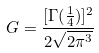<formula> <loc_0><loc_0><loc_500><loc_500>G = \frac { [ \Gamma ( \frac { 1 } { 4 } ) ] ^ { 2 } } { 2 \sqrt { 2 \pi ^ { 3 } } }</formula> 